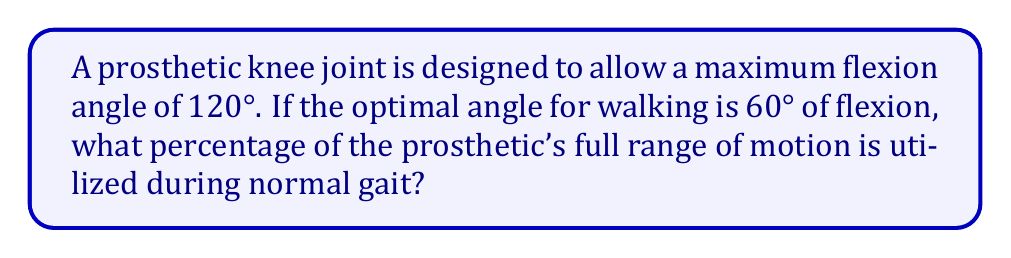What is the answer to this math problem? To solve this problem, we need to follow these steps:

1) First, let's define our variables:
   $\theta_{max}$ = maximum flexion angle = 120°
   $\theta_{opt}$ = optimal angle for walking = 60°

2) The percentage of the full range of motion utilized is the ratio of the optimal angle to the maximum angle, multiplied by 100:

   $$\text{Percentage} = \frac{\theta_{opt}}{\theta_{max}} \times 100\%$$

3) Substituting our values:

   $$\text{Percentage} = \frac{60°}{120°} \times 100\%$$

4) Simplify the fraction:

   $$\text{Percentage} = \frac{1}{2} \times 100\%$$

5) Calculate the final percentage:

   $$\text{Percentage} = 50\%$$

Therefore, during normal gait, 50% of the prosthetic's full range of motion is utilized.
Answer: 50% 